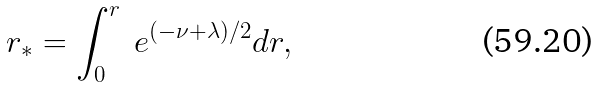Convert formula to latex. <formula><loc_0><loc_0><loc_500><loc_500>r _ { * } = \int _ { 0 } ^ { r } \ e ^ { ( - \nu + \lambda ) / 2 } d r ,</formula> 